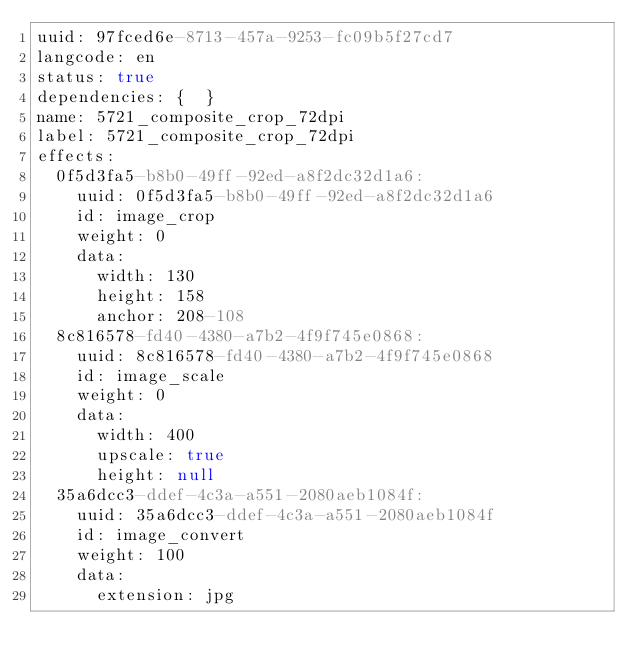<code> <loc_0><loc_0><loc_500><loc_500><_YAML_>uuid: 97fced6e-8713-457a-9253-fc09b5f27cd7
langcode: en
status: true
dependencies: {  }
name: 5721_composite_crop_72dpi
label: 5721_composite_crop_72dpi
effects:
  0f5d3fa5-b8b0-49ff-92ed-a8f2dc32d1a6:
    uuid: 0f5d3fa5-b8b0-49ff-92ed-a8f2dc32d1a6
    id: image_crop
    weight: 0
    data:
      width: 130
      height: 158
      anchor: 208-108
  8c816578-fd40-4380-a7b2-4f9f745e0868:
    uuid: 8c816578-fd40-4380-a7b2-4f9f745e0868
    id: image_scale
    weight: 0
    data:
      width: 400
      upscale: true
      height: null
  35a6dcc3-ddef-4c3a-a551-2080aeb1084f:
    uuid: 35a6dcc3-ddef-4c3a-a551-2080aeb1084f
    id: image_convert
    weight: 100
    data:
      extension: jpg
</code> 